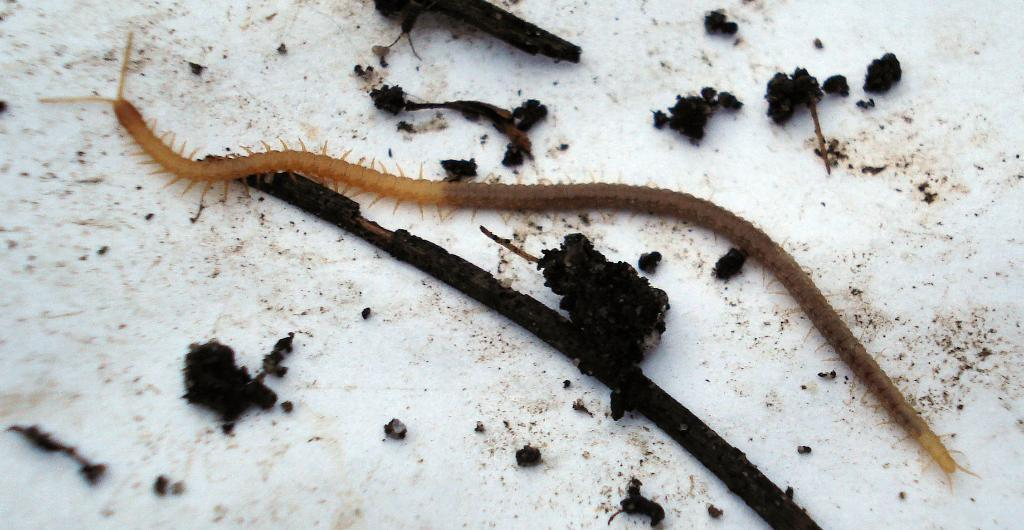What type of creature is present on an object in the image? There is a worm on an object in the image. What type of snail can be seen interacting with the kettle in the image? There is no snail or kettle present in the image; it features a worm on an unspecified object. How does the worm maintain a quiet environment in the image? Worms do not have the ability to control or maintain a quiet environment, and there is no information about the sound level in the image. 